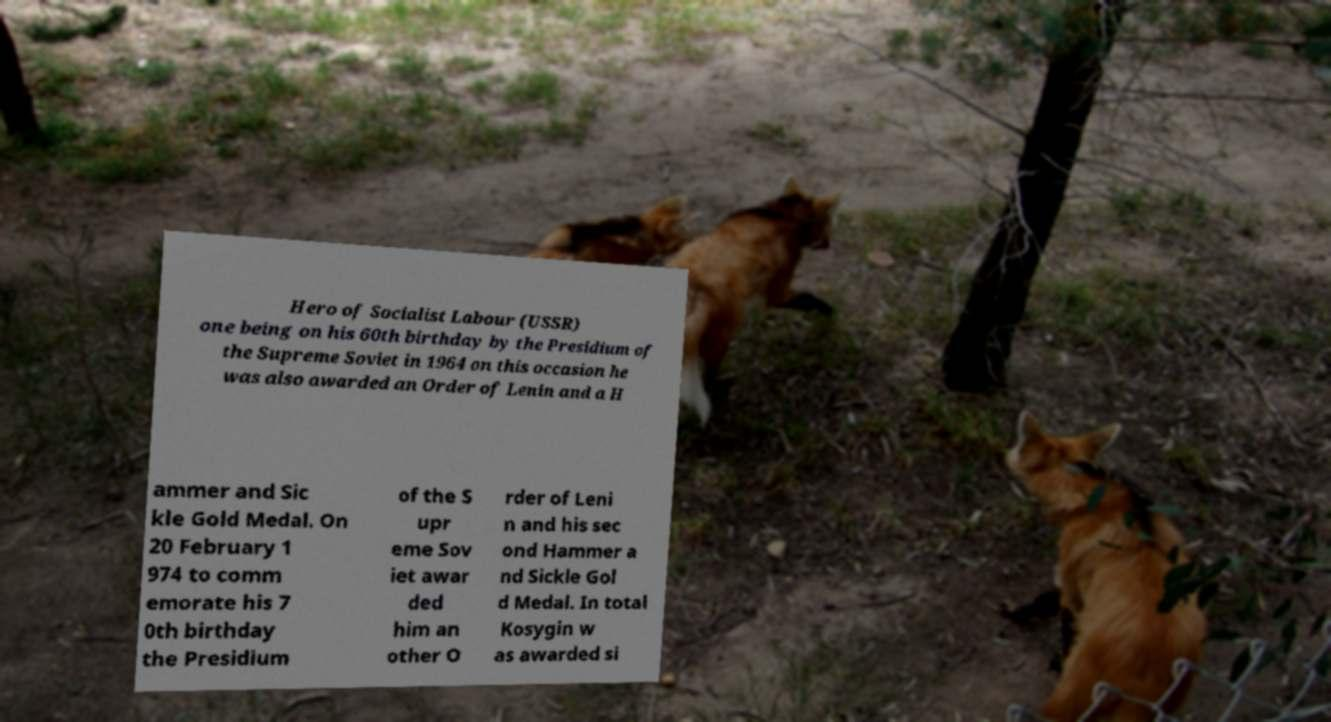For documentation purposes, I need the text within this image transcribed. Could you provide that? Hero of Socialist Labour (USSR) one being on his 60th birthday by the Presidium of the Supreme Soviet in 1964 on this occasion he was also awarded an Order of Lenin and a H ammer and Sic kle Gold Medal. On 20 February 1 974 to comm emorate his 7 0th birthday the Presidium of the S upr eme Sov iet awar ded him an other O rder of Leni n and his sec ond Hammer a nd Sickle Gol d Medal. In total Kosygin w as awarded si 